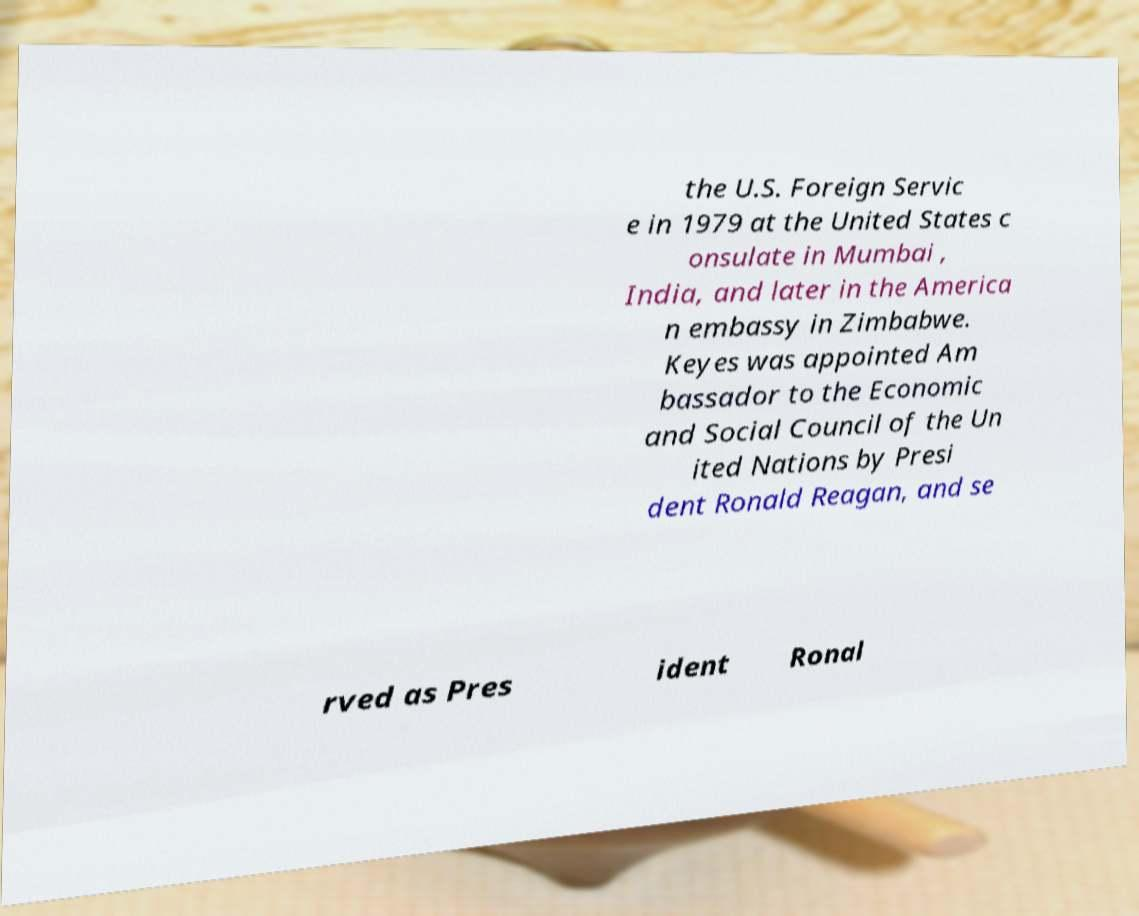Please read and relay the text visible in this image. What does it say? the U.S. Foreign Servic e in 1979 at the United States c onsulate in Mumbai , India, and later in the America n embassy in Zimbabwe. Keyes was appointed Am bassador to the Economic and Social Council of the Un ited Nations by Presi dent Ronald Reagan, and se rved as Pres ident Ronal 